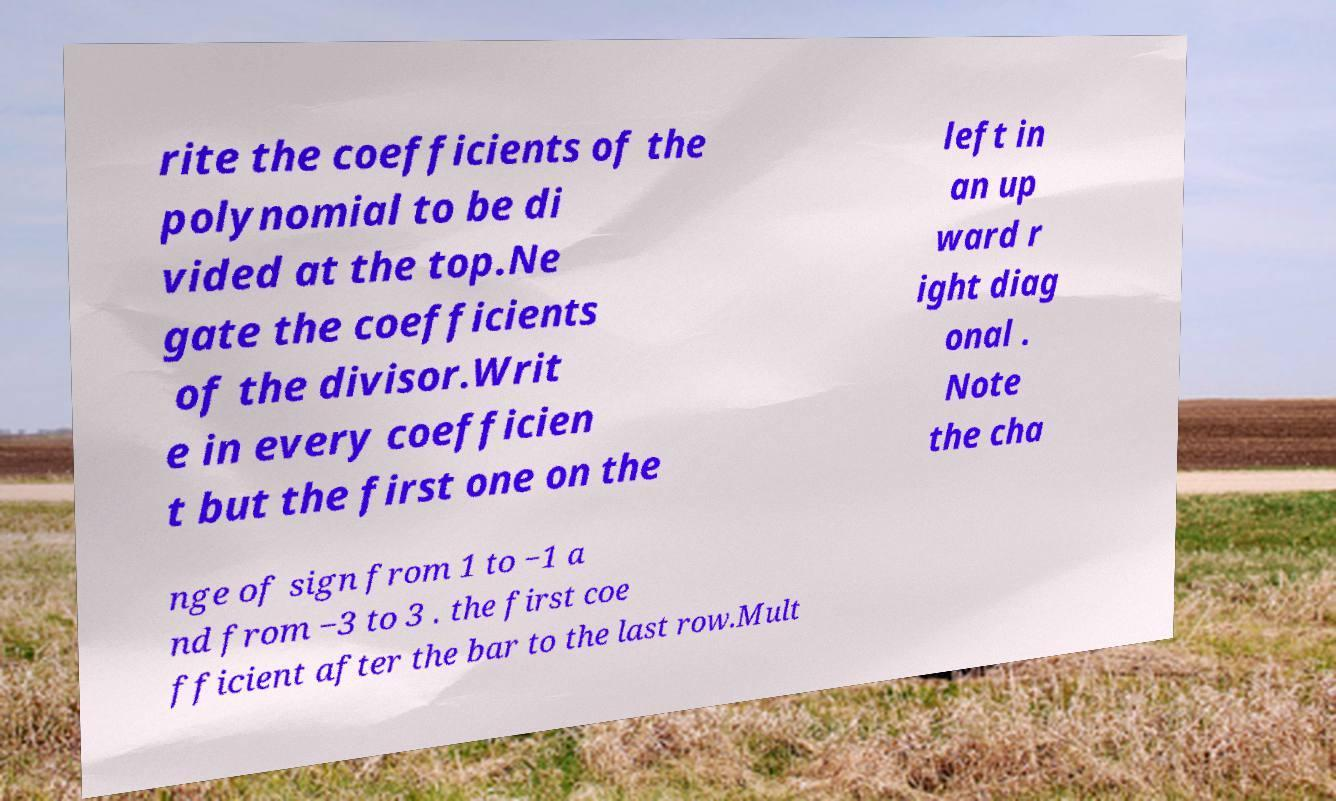Can you accurately transcribe the text from the provided image for me? rite the coefficients of the polynomial to be di vided at the top.Ne gate the coefficients of the divisor.Writ e in every coefficien t but the first one on the left in an up ward r ight diag onal . Note the cha nge of sign from 1 to −1 a nd from −3 to 3 . the first coe fficient after the bar to the last row.Mult 